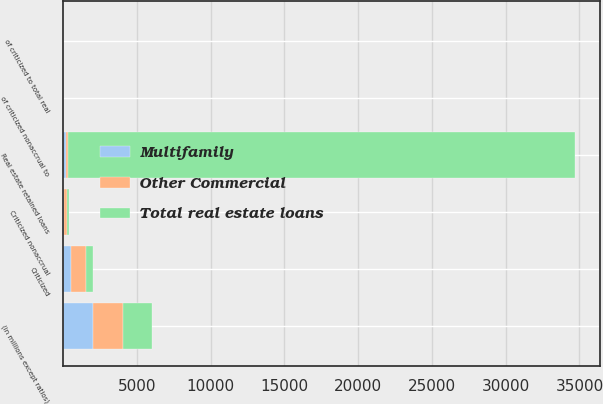<chart> <loc_0><loc_0><loc_500><loc_500><stacked_bar_chart><ecel><fcel>(in millions except ratios)<fcel>Real estate retained loans<fcel>Criticized<fcel>of criticized to total real<fcel>Criticized nonaccrual<fcel>of criticized nonaccrual to<nl><fcel>Multifamily<fcel>2016<fcel>171.5<fcel>539<fcel>0.75<fcel>57<fcel>0.08<nl><fcel>Total real estate loans<fcel>2016<fcel>34337<fcel>459<fcel>1.34<fcel>143<fcel>0.42<nl><fcel>Other Commercial<fcel>2016<fcel>171.5<fcel>998<fcel>0.94<fcel>200<fcel>0.19<nl></chart> 